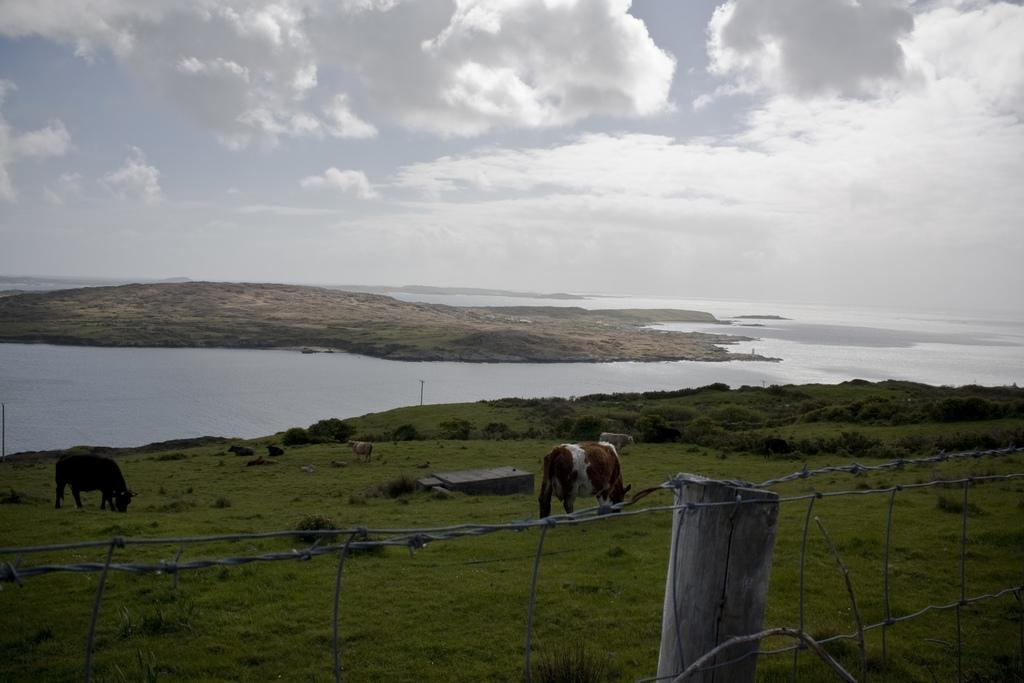What is the primary element visible in the image? There is water in the image. What animals are present in the image? There are cows seated in the image, and some cows are grazing grass. What type of structure can be seen in the image? There is a fence in the image. What is the ground covered with in the image? Grass is present on the ground in the image. What type of vegetation is visible in the image? There are plants in the image. What is the condition of the sky in the image? The sky is cloudy in the image. Where is the nest located in the image? There is no nest present in the image. What type of grass is being used to build the nest in the image? There is no nest or grass being used for nest-building in the image. 